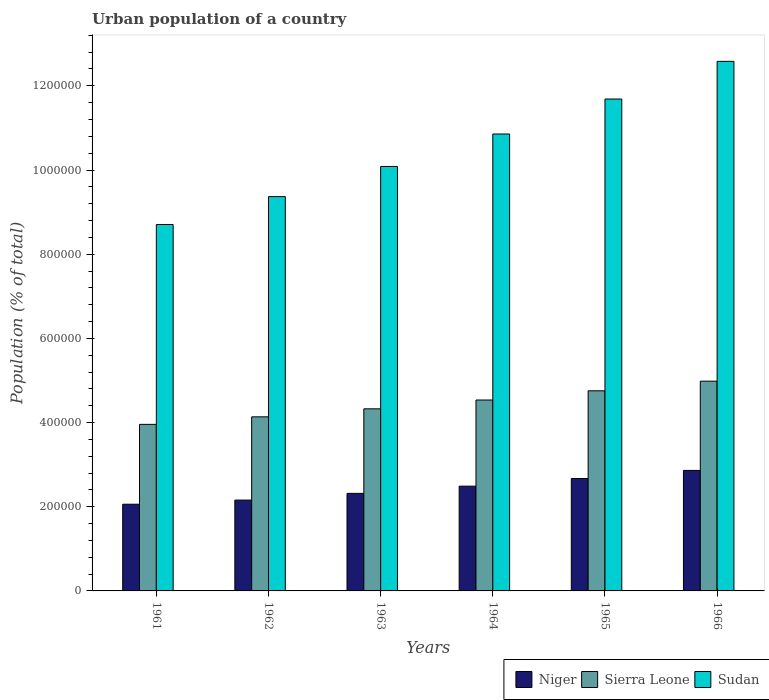How many different coloured bars are there?
Offer a very short reply. 3. What is the label of the 3rd group of bars from the left?
Provide a short and direct response. 1963. What is the urban population in Sudan in 1963?
Offer a very short reply. 1.01e+06. Across all years, what is the maximum urban population in Sudan?
Your answer should be compact. 1.26e+06. Across all years, what is the minimum urban population in Niger?
Your answer should be very brief. 2.06e+05. In which year was the urban population in Niger maximum?
Ensure brevity in your answer.  1966. In which year was the urban population in Sierra Leone minimum?
Your answer should be very brief. 1961. What is the total urban population in Sudan in the graph?
Ensure brevity in your answer.  6.33e+06. What is the difference between the urban population in Sudan in 1962 and that in 1963?
Your answer should be very brief. -7.16e+04. What is the difference between the urban population in Sudan in 1965 and the urban population in Sierra Leone in 1962?
Keep it short and to the point. 7.55e+05. What is the average urban population in Sudan per year?
Provide a succinct answer. 1.05e+06. In the year 1963, what is the difference between the urban population in Sierra Leone and urban population in Niger?
Make the answer very short. 2.01e+05. In how many years, is the urban population in Niger greater than 680000 %?
Your response must be concise. 0. What is the ratio of the urban population in Sudan in 1961 to that in 1962?
Provide a short and direct response. 0.93. What is the difference between the highest and the second highest urban population in Sudan?
Keep it short and to the point. 8.95e+04. What is the difference between the highest and the lowest urban population in Sierra Leone?
Your response must be concise. 1.03e+05. In how many years, is the urban population in Niger greater than the average urban population in Niger taken over all years?
Provide a succinct answer. 3. Is the sum of the urban population in Sierra Leone in 1961 and 1962 greater than the maximum urban population in Sudan across all years?
Offer a terse response. No. What does the 2nd bar from the left in 1961 represents?
Give a very brief answer. Sierra Leone. What does the 3rd bar from the right in 1965 represents?
Your response must be concise. Niger. Are all the bars in the graph horizontal?
Your response must be concise. No. How many years are there in the graph?
Your answer should be compact. 6. Does the graph contain any zero values?
Provide a succinct answer. No. Does the graph contain grids?
Provide a short and direct response. No. What is the title of the graph?
Keep it short and to the point. Urban population of a country. What is the label or title of the Y-axis?
Give a very brief answer. Population (% of total). What is the Population (% of total) in Niger in 1961?
Your answer should be compact. 2.06e+05. What is the Population (% of total) in Sierra Leone in 1961?
Make the answer very short. 3.96e+05. What is the Population (% of total) in Sudan in 1961?
Keep it short and to the point. 8.70e+05. What is the Population (% of total) of Niger in 1962?
Ensure brevity in your answer.  2.16e+05. What is the Population (% of total) of Sierra Leone in 1962?
Your answer should be very brief. 4.14e+05. What is the Population (% of total) in Sudan in 1962?
Offer a terse response. 9.37e+05. What is the Population (% of total) of Niger in 1963?
Provide a short and direct response. 2.32e+05. What is the Population (% of total) in Sierra Leone in 1963?
Your answer should be compact. 4.33e+05. What is the Population (% of total) in Sudan in 1963?
Your answer should be compact. 1.01e+06. What is the Population (% of total) in Niger in 1964?
Ensure brevity in your answer.  2.49e+05. What is the Population (% of total) in Sierra Leone in 1964?
Give a very brief answer. 4.54e+05. What is the Population (% of total) in Sudan in 1964?
Make the answer very short. 1.09e+06. What is the Population (% of total) in Niger in 1965?
Your response must be concise. 2.67e+05. What is the Population (% of total) of Sierra Leone in 1965?
Offer a very short reply. 4.75e+05. What is the Population (% of total) in Sudan in 1965?
Your answer should be compact. 1.17e+06. What is the Population (% of total) of Niger in 1966?
Offer a very short reply. 2.86e+05. What is the Population (% of total) in Sierra Leone in 1966?
Give a very brief answer. 4.98e+05. What is the Population (% of total) in Sudan in 1966?
Provide a succinct answer. 1.26e+06. Across all years, what is the maximum Population (% of total) in Niger?
Your response must be concise. 2.86e+05. Across all years, what is the maximum Population (% of total) in Sierra Leone?
Your answer should be very brief. 4.98e+05. Across all years, what is the maximum Population (% of total) in Sudan?
Give a very brief answer. 1.26e+06. Across all years, what is the minimum Population (% of total) of Niger?
Your answer should be compact. 2.06e+05. Across all years, what is the minimum Population (% of total) in Sierra Leone?
Make the answer very short. 3.96e+05. Across all years, what is the minimum Population (% of total) in Sudan?
Make the answer very short. 8.70e+05. What is the total Population (% of total) of Niger in the graph?
Your response must be concise. 1.46e+06. What is the total Population (% of total) in Sierra Leone in the graph?
Ensure brevity in your answer.  2.67e+06. What is the total Population (% of total) in Sudan in the graph?
Your answer should be very brief. 6.33e+06. What is the difference between the Population (% of total) of Niger in 1961 and that in 1962?
Provide a short and direct response. -9812. What is the difference between the Population (% of total) in Sierra Leone in 1961 and that in 1962?
Your response must be concise. -1.79e+04. What is the difference between the Population (% of total) in Sudan in 1961 and that in 1962?
Give a very brief answer. -6.64e+04. What is the difference between the Population (% of total) of Niger in 1961 and that in 1963?
Offer a very short reply. -2.58e+04. What is the difference between the Population (% of total) in Sierra Leone in 1961 and that in 1963?
Ensure brevity in your answer.  -3.70e+04. What is the difference between the Population (% of total) of Sudan in 1961 and that in 1963?
Ensure brevity in your answer.  -1.38e+05. What is the difference between the Population (% of total) of Niger in 1961 and that in 1964?
Provide a succinct answer. -4.29e+04. What is the difference between the Population (% of total) in Sierra Leone in 1961 and that in 1964?
Provide a short and direct response. -5.79e+04. What is the difference between the Population (% of total) in Sudan in 1961 and that in 1964?
Offer a very short reply. -2.15e+05. What is the difference between the Population (% of total) of Niger in 1961 and that in 1965?
Provide a succinct answer. -6.10e+04. What is the difference between the Population (% of total) in Sierra Leone in 1961 and that in 1965?
Your answer should be compact. -7.98e+04. What is the difference between the Population (% of total) in Sudan in 1961 and that in 1965?
Provide a succinct answer. -2.98e+05. What is the difference between the Population (% of total) of Niger in 1961 and that in 1966?
Offer a very short reply. -8.03e+04. What is the difference between the Population (% of total) in Sierra Leone in 1961 and that in 1966?
Offer a very short reply. -1.03e+05. What is the difference between the Population (% of total) of Sudan in 1961 and that in 1966?
Your answer should be very brief. -3.88e+05. What is the difference between the Population (% of total) of Niger in 1962 and that in 1963?
Provide a short and direct response. -1.60e+04. What is the difference between the Population (% of total) in Sierra Leone in 1962 and that in 1963?
Your answer should be very brief. -1.91e+04. What is the difference between the Population (% of total) of Sudan in 1962 and that in 1963?
Give a very brief answer. -7.16e+04. What is the difference between the Population (% of total) in Niger in 1962 and that in 1964?
Make the answer very short. -3.31e+04. What is the difference between the Population (% of total) in Sierra Leone in 1962 and that in 1964?
Ensure brevity in your answer.  -4.00e+04. What is the difference between the Population (% of total) in Sudan in 1962 and that in 1964?
Ensure brevity in your answer.  -1.49e+05. What is the difference between the Population (% of total) of Niger in 1962 and that in 1965?
Offer a terse response. -5.12e+04. What is the difference between the Population (% of total) in Sierra Leone in 1962 and that in 1965?
Your response must be concise. -6.19e+04. What is the difference between the Population (% of total) in Sudan in 1962 and that in 1965?
Ensure brevity in your answer.  -2.32e+05. What is the difference between the Population (% of total) in Niger in 1962 and that in 1966?
Ensure brevity in your answer.  -7.05e+04. What is the difference between the Population (% of total) of Sierra Leone in 1962 and that in 1966?
Ensure brevity in your answer.  -8.47e+04. What is the difference between the Population (% of total) in Sudan in 1962 and that in 1966?
Provide a succinct answer. -3.21e+05. What is the difference between the Population (% of total) of Niger in 1963 and that in 1964?
Make the answer very short. -1.71e+04. What is the difference between the Population (% of total) of Sierra Leone in 1963 and that in 1964?
Your answer should be compact. -2.09e+04. What is the difference between the Population (% of total) of Sudan in 1963 and that in 1964?
Your answer should be very brief. -7.72e+04. What is the difference between the Population (% of total) in Niger in 1963 and that in 1965?
Offer a terse response. -3.52e+04. What is the difference between the Population (% of total) in Sierra Leone in 1963 and that in 1965?
Provide a short and direct response. -4.28e+04. What is the difference between the Population (% of total) in Sudan in 1963 and that in 1965?
Provide a short and direct response. -1.60e+05. What is the difference between the Population (% of total) in Niger in 1963 and that in 1966?
Provide a short and direct response. -5.45e+04. What is the difference between the Population (% of total) in Sierra Leone in 1963 and that in 1966?
Offer a very short reply. -6.57e+04. What is the difference between the Population (% of total) of Sudan in 1963 and that in 1966?
Offer a very short reply. -2.50e+05. What is the difference between the Population (% of total) in Niger in 1964 and that in 1965?
Your answer should be very brief. -1.81e+04. What is the difference between the Population (% of total) in Sierra Leone in 1964 and that in 1965?
Your answer should be compact. -2.19e+04. What is the difference between the Population (% of total) of Sudan in 1964 and that in 1965?
Your answer should be very brief. -8.31e+04. What is the difference between the Population (% of total) of Niger in 1964 and that in 1966?
Keep it short and to the point. -3.74e+04. What is the difference between the Population (% of total) of Sierra Leone in 1964 and that in 1966?
Your answer should be very brief. -4.48e+04. What is the difference between the Population (% of total) in Sudan in 1964 and that in 1966?
Your answer should be compact. -1.73e+05. What is the difference between the Population (% of total) in Niger in 1965 and that in 1966?
Ensure brevity in your answer.  -1.93e+04. What is the difference between the Population (% of total) of Sierra Leone in 1965 and that in 1966?
Keep it short and to the point. -2.29e+04. What is the difference between the Population (% of total) in Sudan in 1965 and that in 1966?
Offer a terse response. -8.95e+04. What is the difference between the Population (% of total) of Niger in 1961 and the Population (% of total) of Sierra Leone in 1962?
Provide a succinct answer. -2.08e+05. What is the difference between the Population (% of total) in Niger in 1961 and the Population (% of total) in Sudan in 1962?
Your answer should be compact. -7.31e+05. What is the difference between the Population (% of total) in Sierra Leone in 1961 and the Population (% of total) in Sudan in 1962?
Provide a short and direct response. -5.41e+05. What is the difference between the Population (% of total) in Niger in 1961 and the Population (% of total) in Sierra Leone in 1963?
Keep it short and to the point. -2.27e+05. What is the difference between the Population (% of total) in Niger in 1961 and the Population (% of total) in Sudan in 1963?
Make the answer very short. -8.02e+05. What is the difference between the Population (% of total) of Sierra Leone in 1961 and the Population (% of total) of Sudan in 1963?
Your answer should be compact. -6.13e+05. What is the difference between the Population (% of total) of Niger in 1961 and the Population (% of total) of Sierra Leone in 1964?
Your answer should be very brief. -2.48e+05. What is the difference between the Population (% of total) of Niger in 1961 and the Population (% of total) of Sudan in 1964?
Your response must be concise. -8.80e+05. What is the difference between the Population (% of total) of Sierra Leone in 1961 and the Population (% of total) of Sudan in 1964?
Ensure brevity in your answer.  -6.90e+05. What is the difference between the Population (% of total) of Niger in 1961 and the Population (% of total) of Sierra Leone in 1965?
Your answer should be very brief. -2.69e+05. What is the difference between the Population (% of total) in Niger in 1961 and the Population (% of total) in Sudan in 1965?
Ensure brevity in your answer.  -9.63e+05. What is the difference between the Population (% of total) of Sierra Leone in 1961 and the Population (% of total) of Sudan in 1965?
Offer a terse response. -7.73e+05. What is the difference between the Population (% of total) of Niger in 1961 and the Population (% of total) of Sierra Leone in 1966?
Keep it short and to the point. -2.92e+05. What is the difference between the Population (% of total) in Niger in 1961 and the Population (% of total) in Sudan in 1966?
Your answer should be compact. -1.05e+06. What is the difference between the Population (% of total) of Sierra Leone in 1961 and the Population (% of total) of Sudan in 1966?
Your answer should be very brief. -8.62e+05. What is the difference between the Population (% of total) in Niger in 1962 and the Population (% of total) in Sierra Leone in 1963?
Offer a very short reply. -2.17e+05. What is the difference between the Population (% of total) of Niger in 1962 and the Population (% of total) of Sudan in 1963?
Provide a succinct answer. -7.93e+05. What is the difference between the Population (% of total) in Sierra Leone in 1962 and the Population (% of total) in Sudan in 1963?
Give a very brief answer. -5.95e+05. What is the difference between the Population (% of total) of Niger in 1962 and the Population (% of total) of Sierra Leone in 1964?
Make the answer very short. -2.38e+05. What is the difference between the Population (% of total) in Niger in 1962 and the Population (% of total) in Sudan in 1964?
Provide a succinct answer. -8.70e+05. What is the difference between the Population (% of total) in Sierra Leone in 1962 and the Population (% of total) in Sudan in 1964?
Ensure brevity in your answer.  -6.72e+05. What is the difference between the Population (% of total) in Niger in 1962 and the Population (% of total) in Sierra Leone in 1965?
Provide a short and direct response. -2.60e+05. What is the difference between the Population (% of total) of Niger in 1962 and the Population (% of total) of Sudan in 1965?
Keep it short and to the point. -9.53e+05. What is the difference between the Population (% of total) of Sierra Leone in 1962 and the Population (% of total) of Sudan in 1965?
Provide a short and direct response. -7.55e+05. What is the difference between the Population (% of total) in Niger in 1962 and the Population (% of total) in Sierra Leone in 1966?
Your answer should be compact. -2.83e+05. What is the difference between the Population (% of total) in Niger in 1962 and the Population (% of total) in Sudan in 1966?
Keep it short and to the point. -1.04e+06. What is the difference between the Population (% of total) of Sierra Leone in 1962 and the Population (% of total) of Sudan in 1966?
Make the answer very short. -8.45e+05. What is the difference between the Population (% of total) of Niger in 1963 and the Population (% of total) of Sierra Leone in 1964?
Make the answer very short. -2.22e+05. What is the difference between the Population (% of total) in Niger in 1963 and the Population (% of total) in Sudan in 1964?
Your answer should be very brief. -8.54e+05. What is the difference between the Population (% of total) of Sierra Leone in 1963 and the Population (% of total) of Sudan in 1964?
Keep it short and to the point. -6.53e+05. What is the difference between the Population (% of total) of Niger in 1963 and the Population (% of total) of Sierra Leone in 1965?
Make the answer very short. -2.44e+05. What is the difference between the Population (% of total) of Niger in 1963 and the Population (% of total) of Sudan in 1965?
Your answer should be compact. -9.37e+05. What is the difference between the Population (% of total) in Sierra Leone in 1963 and the Population (% of total) in Sudan in 1965?
Your answer should be compact. -7.36e+05. What is the difference between the Population (% of total) of Niger in 1963 and the Population (% of total) of Sierra Leone in 1966?
Keep it short and to the point. -2.67e+05. What is the difference between the Population (% of total) in Niger in 1963 and the Population (% of total) in Sudan in 1966?
Your answer should be compact. -1.03e+06. What is the difference between the Population (% of total) in Sierra Leone in 1963 and the Population (% of total) in Sudan in 1966?
Provide a short and direct response. -8.25e+05. What is the difference between the Population (% of total) in Niger in 1964 and the Population (% of total) in Sierra Leone in 1965?
Provide a succinct answer. -2.27e+05. What is the difference between the Population (% of total) in Niger in 1964 and the Population (% of total) in Sudan in 1965?
Your answer should be compact. -9.20e+05. What is the difference between the Population (% of total) in Sierra Leone in 1964 and the Population (% of total) in Sudan in 1965?
Your response must be concise. -7.15e+05. What is the difference between the Population (% of total) in Niger in 1964 and the Population (% of total) in Sierra Leone in 1966?
Make the answer very short. -2.49e+05. What is the difference between the Population (% of total) of Niger in 1964 and the Population (% of total) of Sudan in 1966?
Provide a succinct answer. -1.01e+06. What is the difference between the Population (% of total) of Sierra Leone in 1964 and the Population (% of total) of Sudan in 1966?
Provide a succinct answer. -8.05e+05. What is the difference between the Population (% of total) of Niger in 1965 and the Population (% of total) of Sierra Leone in 1966?
Keep it short and to the point. -2.31e+05. What is the difference between the Population (% of total) in Niger in 1965 and the Population (% of total) in Sudan in 1966?
Keep it short and to the point. -9.91e+05. What is the difference between the Population (% of total) in Sierra Leone in 1965 and the Population (% of total) in Sudan in 1966?
Provide a succinct answer. -7.83e+05. What is the average Population (% of total) of Niger per year?
Make the answer very short. 2.43e+05. What is the average Population (% of total) of Sierra Leone per year?
Offer a terse response. 4.45e+05. What is the average Population (% of total) in Sudan per year?
Your answer should be very brief. 1.05e+06. In the year 1961, what is the difference between the Population (% of total) of Niger and Population (% of total) of Sierra Leone?
Provide a succinct answer. -1.90e+05. In the year 1961, what is the difference between the Population (% of total) in Niger and Population (% of total) in Sudan?
Give a very brief answer. -6.64e+05. In the year 1961, what is the difference between the Population (% of total) of Sierra Leone and Population (% of total) of Sudan?
Provide a succinct answer. -4.75e+05. In the year 1962, what is the difference between the Population (% of total) in Niger and Population (% of total) in Sierra Leone?
Your response must be concise. -1.98e+05. In the year 1962, what is the difference between the Population (% of total) in Niger and Population (% of total) in Sudan?
Your answer should be compact. -7.21e+05. In the year 1962, what is the difference between the Population (% of total) of Sierra Leone and Population (% of total) of Sudan?
Give a very brief answer. -5.23e+05. In the year 1963, what is the difference between the Population (% of total) in Niger and Population (% of total) in Sierra Leone?
Give a very brief answer. -2.01e+05. In the year 1963, what is the difference between the Population (% of total) of Niger and Population (% of total) of Sudan?
Offer a terse response. -7.77e+05. In the year 1963, what is the difference between the Population (% of total) of Sierra Leone and Population (% of total) of Sudan?
Your answer should be compact. -5.76e+05. In the year 1964, what is the difference between the Population (% of total) in Niger and Population (% of total) in Sierra Leone?
Your answer should be compact. -2.05e+05. In the year 1964, what is the difference between the Population (% of total) of Niger and Population (% of total) of Sudan?
Your answer should be compact. -8.37e+05. In the year 1964, what is the difference between the Population (% of total) in Sierra Leone and Population (% of total) in Sudan?
Your answer should be very brief. -6.32e+05. In the year 1965, what is the difference between the Population (% of total) of Niger and Population (% of total) of Sierra Leone?
Keep it short and to the point. -2.08e+05. In the year 1965, what is the difference between the Population (% of total) in Niger and Population (% of total) in Sudan?
Provide a succinct answer. -9.02e+05. In the year 1965, what is the difference between the Population (% of total) in Sierra Leone and Population (% of total) in Sudan?
Provide a short and direct response. -6.93e+05. In the year 1966, what is the difference between the Population (% of total) in Niger and Population (% of total) in Sierra Leone?
Offer a very short reply. -2.12e+05. In the year 1966, what is the difference between the Population (% of total) of Niger and Population (% of total) of Sudan?
Your answer should be very brief. -9.72e+05. In the year 1966, what is the difference between the Population (% of total) of Sierra Leone and Population (% of total) of Sudan?
Ensure brevity in your answer.  -7.60e+05. What is the ratio of the Population (% of total) in Niger in 1961 to that in 1962?
Your response must be concise. 0.95. What is the ratio of the Population (% of total) of Sierra Leone in 1961 to that in 1962?
Your response must be concise. 0.96. What is the ratio of the Population (% of total) in Sudan in 1961 to that in 1962?
Provide a succinct answer. 0.93. What is the ratio of the Population (% of total) of Niger in 1961 to that in 1963?
Make the answer very short. 0.89. What is the ratio of the Population (% of total) in Sierra Leone in 1961 to that in 1963?
Offer a very short reply. 0.91. What is the ratio of the Population (% of total) of Sudan in 1961 to that in 1963?
Provide a short and direct response. 0.86. What is the ratio of the Population (% of total) of Niger in 1961 to that in 1964?
Your answer should be compact. 0.83. What is the ratio of the Population (% of total) of Sierra Leone in 1961 to that in 1964?
Offer a very short reply. 0.87. What is the ratio of the Population (% of total) in Sudan in 1961 to that in 1964?
Ensure brevity in your answer.  0.8. What is the ratio of the Population (% of total) in Niger in 1961 to that in 1965?
Give a very brief answer. 0.77. What is the ratio of the Population (% of total) of Sierra Leone in 1961 to that in 1965?
Provide a succinct answer. 0.83. What is the ratio of the Population (% of total) in Sudan in 1961 to that in 1965?
Your answer should be very brief. 0.74. What is the ratio of the Population (% of total) in Niger in 1961 to that in 1966?
Offer a terse response. 0.72. What is the ratio of the Population (% of total) in Sierra Leone in 1961 to that in 1966?
Offer a terse response. 0.79. What is the ratio of the Population (% of total) in Sudan in 1961 to that in 1966?
Provide a succinct answer. 0.69. What is the ratio of the Population (% of total) of Niger in 1962 to that in 1963?
Offer a very short reply. 0.93. What is the ratio of the Population (% of total) in Sierra Leone in 1962 to that in 1963?
Provide a succinct answer. 0.96. What is the ratio of the Population (% of total) of Sudan in 1962 to that in 1963?
Make the answer very short. 0.93. What is the ratio of the Population (% of total) of Niger in 1962 to that in 1964?
Offer a terse response. 0.87. What is the ratio of the Population (% of total) in Sierra Leone in 1962 to that in 1964?
Ensure brevity in your answer.  0.91. What is the ratio of the Population (% of total) in Sudan in 1962 to that in 1964?
Give a very brief answer. 0.86. What is the ratio of the Population (% of total) in Niger in 1962 to that in 1965?
Your response must be concise. 0.81. What is the ratio of the Population (% of total) of Sierra Leone in 1962 to that in 1965?
Keep it short and to the point. 0.87. What is the ratio of the Population (% of total) in Sudan in 1962 to that in 1965?
Give a very brief answer. 0.8. What is the ratio of the Population (% of total) in Niger in 1962 to that in 1966?
Provide a succinct answer. 0.75. What is the ratio of the Population (% of total) in Sierra Leone in 1962 to that in 1966?
Your answer should be very brief. 0.83. What is the ratio of the Population (% of total) of Sudan in 1962 to that in 1966?
Provide a short and direct response. 0.74. What is the ratio of the Population (% of total) in Niger in 1963 to that in 1964?
Give a very brief answer. 0.93. What is the ratio of the Population (% of total) in Sierra Leone in 1963 to that in 1964?
Give a very brief answer. 0.95. What is the ratio of the Population (% of total) in Sudan in 1963 to that in 1964?
Your answer should be compact. 0.93. What is the ratio of the Population (% of total) of Niger in 1963 to that in 1965?
Your response must be concise. 0.87. What is the ratio of the Population (% of total) in Sierra Leone in 1963 to that in 1965?
Offer a very short reply. 0.91. What is the ratio of the Population (% of total) in Sudan in 1963 to that in 1965?
Your answer should be very brief. 0.86. What is the ratio of the Population (% of total) of Niger in 1963 to that in 1966?
Keep it short and to the point. 0.81. What is the ratio of the Population (% of total) in Sierra Leone in 1963 to that in 1966?
Offer a terse response. 0.87. What is the ratio of the Population (% of total) of Sudan in 1963 to that in 1966?
Your answer should be compact. 0.8. What is the ratio of the Population (% of total) of Niger in 1964 to that in 1965?
Provide a succinct answer. 0.93. What is the ratio of the Population (% of total) of Sierra Leone in 1964 to that in 1965?
Ensure brevity in your answer.  0.95. What is the ratio of the Population (% of total) in Sudan in 1964 to that in 1965?
Your answer should be very brief. 0.93. What is the ratio of the Population (% of total) in Niger in 1964 to that in 1966?
Your response must be concise. 0.87. What is the ratio of the Population (% of total) in Sierra Leone in 1964 to that in 1966?
Provide a short and direct response. 0.91. What is the ratio of the Population (% of total) of Sudan in 1964 to that in 1966?
Provide a short and direct response. 0.86. What is the ratio of the Population (% of total) of Niger in 1965 to that in 1966?
Give a very brief answer. 0.93. What is the ratio of the Population (% of total) in Sierra Leone in 1965 to that in 1966?
Keep it short and to the point. 0.95. What is the ratio of the Population (% of total) in Sudan in 1965 to that in 1966?
Keep it short and to the point. 0.93. What is the difference between the highest and the second highest Population (% of total) of Niger?
Provide a succinct answer. 1.93e+04. What is the difference between the highest and the second highest Population (% of total) of Sierra Leone?
Your response must be concise. 2.29e+04. What is the difference between the highest and the second highest Population (% of total) in Sudan?
Ensure brevity in your answer.  8.95e+04. What is the difference between the highest and the lowest Population (% of total) of Niger?
Give a very brief answer. 8.03e+04. What is the difference between the highest and the lowest Population (% of total) of Sierra Leone?
Your answer should be very brief. 1.03e+05. What is the difference between the highest and the lowest Population (% of total) in Sudan?
Offer a very short reply. 3.88e+05. 